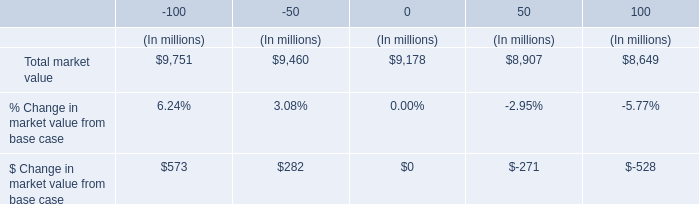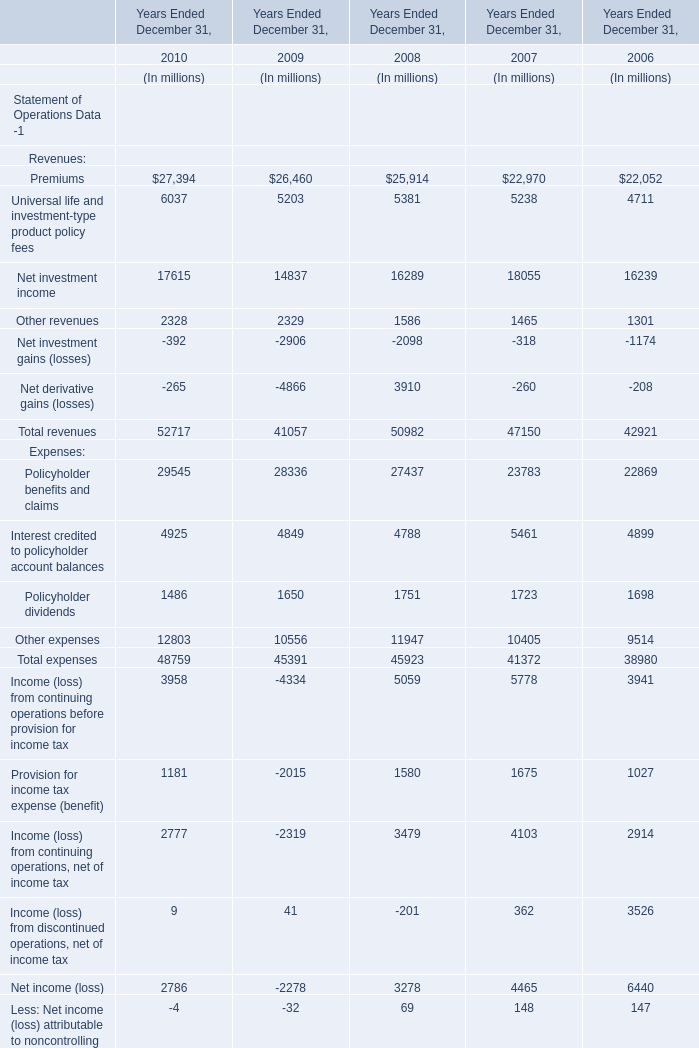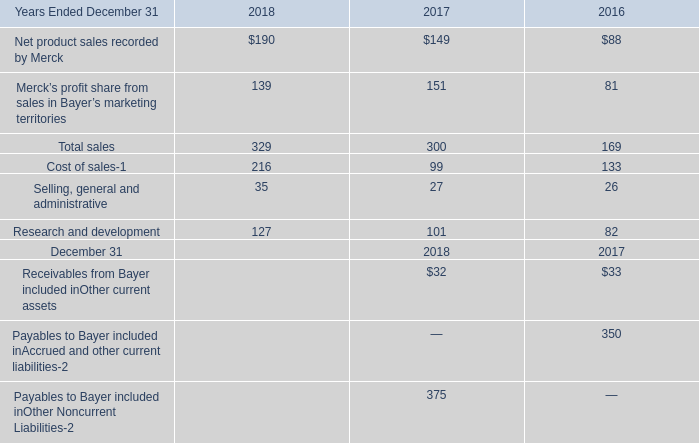What's the current growth rate of Total revenues? (in %) 
Computations: ((52717 - 41057) / 41057)
Answer: 0.284. 